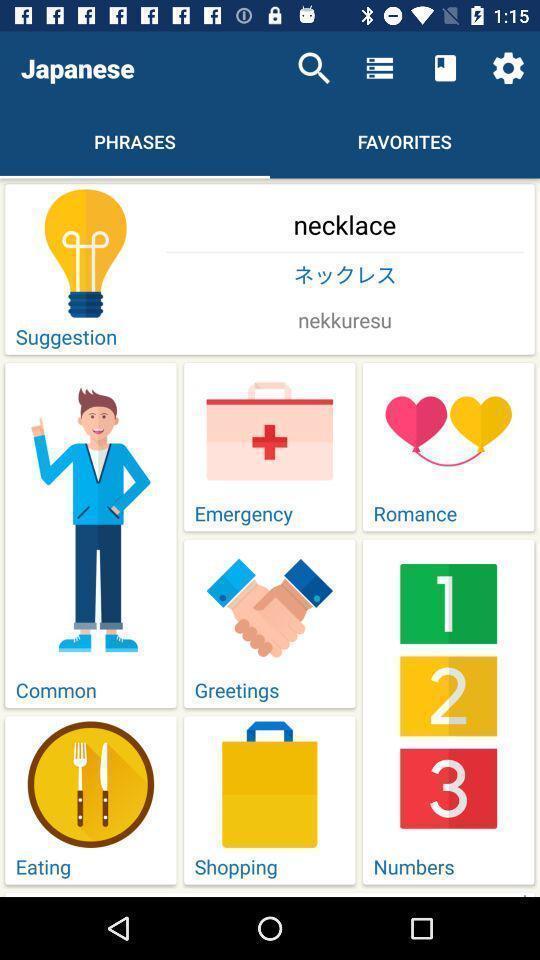Tell me what you see in this picture. Screen showing phrases page. 